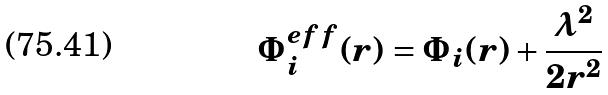Convert formula to latex. <formula><loc_0><loc_0><loc_500><loc_500>\Phi _ { i } ^ { e f f } ( r ) = \Phi _ { i } ( r ) + \frac { \lambda ^ { 2 } } { 2 r ^ { 2 } }</formula> 